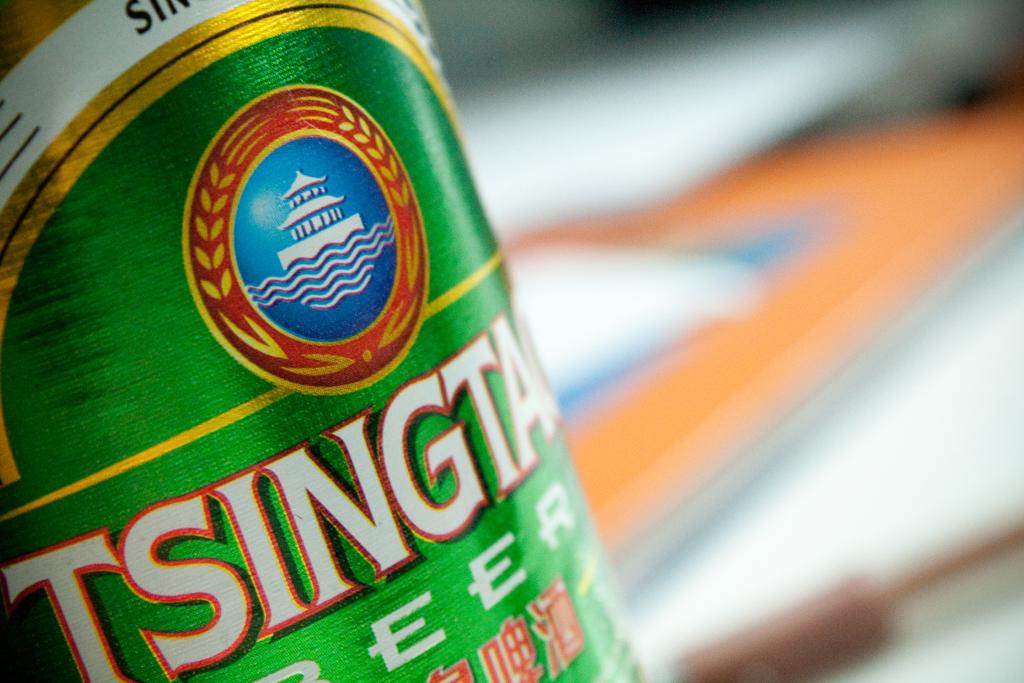<image>
Describe the image concisely. Asian style beer in a green can with Tsingta part of the brand name. 